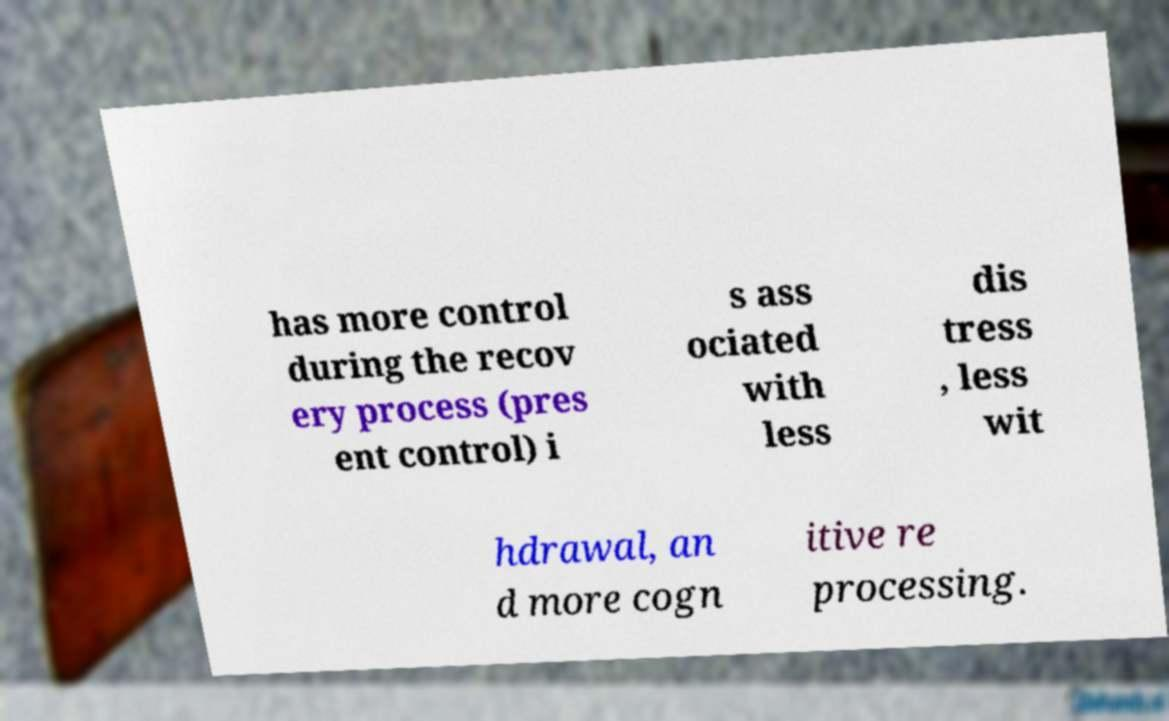Could you assist in decoding the text presented in this image and type it out clearly? has more control during the recov ery process (pres ent control) i s ass ociated with less dis tress , less wit hdrawal, an d more cogn itive re processing. 